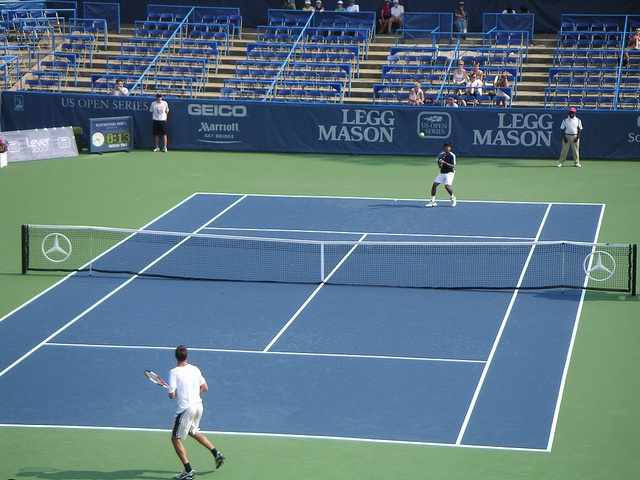Describe the objects in this image and their specific colors. I can see people in gray, black, navy, and blue tones, people in gray, white, black, and darkgray tones, bench in gray, navy, blue, and black tones, people in gray, black, white, and darkgray tones, and people in gray, black, lightgray, and darkgray tones in this image. 